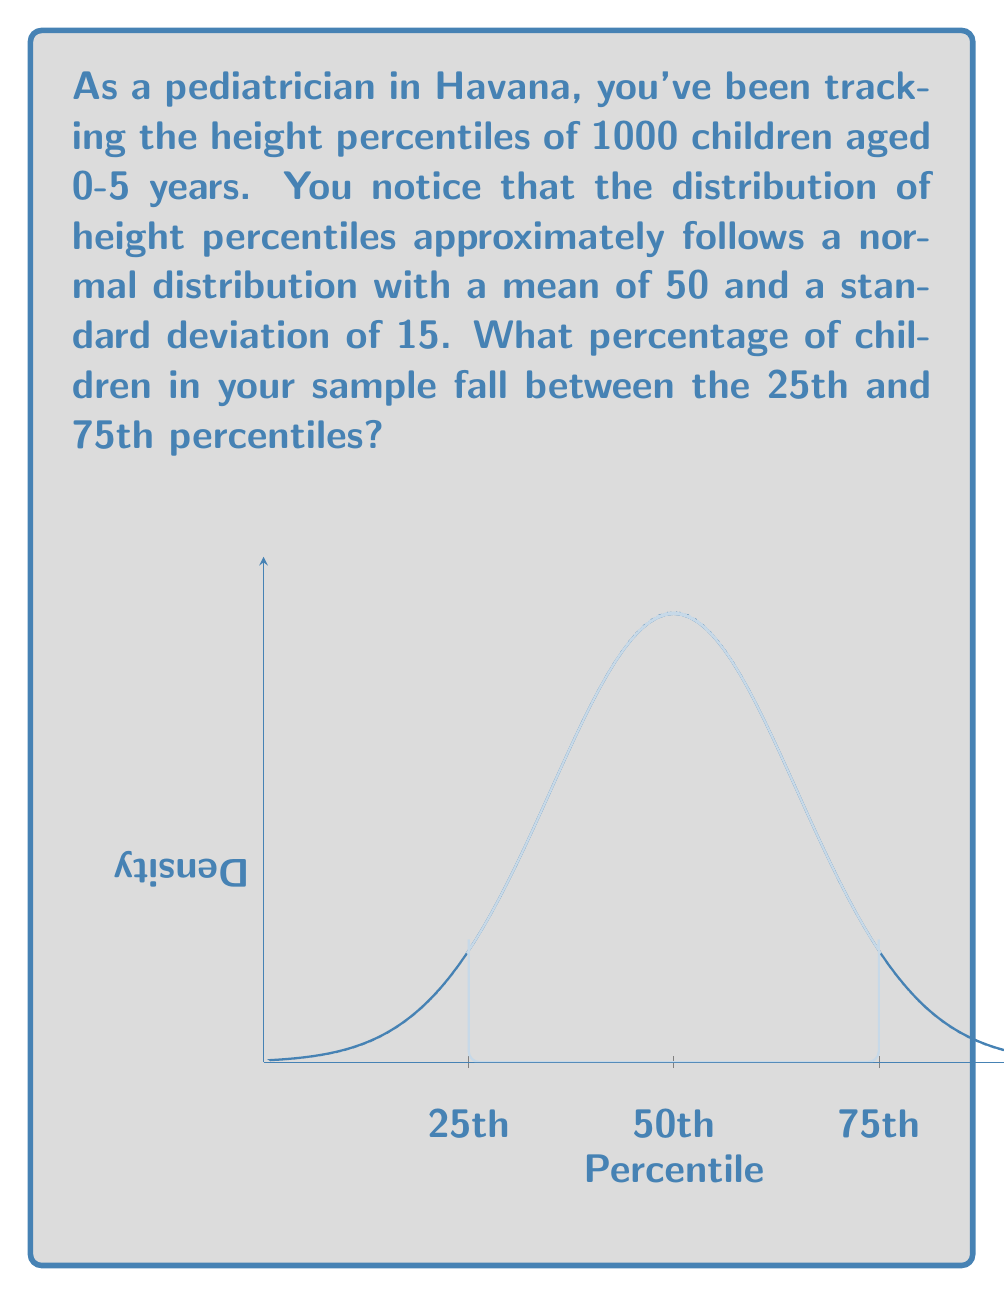Show me your answer to this math problem. Let's approach this step-by-step:

1) The question states that the height percentiles follow a normal distribution with $\mu = 50$ and $\sigma = 15$.

2) We need to find the area under the normal curve between the 25th and 75th percentiles.

3) In a normal distribution, we can calculate this using the z-score formula:

   $z = \frac{x - \mu}{\sigma}$

4) For the 25th percentile:
   $z_{25} = \frac{25 - 50}{15} = -1.67$

5) For the 75th percentile:
   $z_{75} = \frac{75 - 50}{15} = 1.67$

6) Now, we need to find the area between these two z-scores. In a standard normal distribution, this is equivalent to:

   $P(-1.67 < Z < 1.67)$

7) Using a standard normal distribution table or calculator:
   $P(Z < 1.67) - P(Z < -1.67) = 0.9525 - 0.0475 = 0.9050$

8) Convert to a percentage: $0.9050 * 100 = 90.50\%$

Therefore, approximately 90.50% of the children in your sample fall between the 25th and 75th percentiles.
Answer: 90.50% 